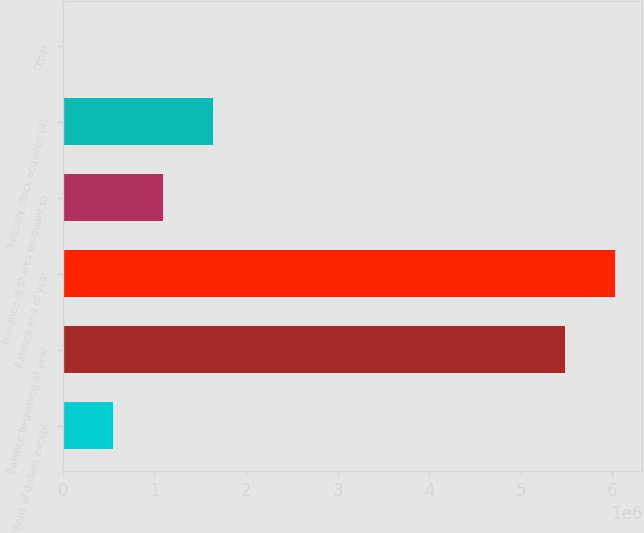Convert chart. <chart><loc_0><loc_0><loc_500><loc_500><bar_chart><fcel>In millions of dollars except<fcel>Balance beginning of year<fcel>Balance end of year<fcel>Issuance of shares pursuant to<fcel>Treasury stock acquired (4)<fcel>Other<nl><fcel>547896<fcel>5.47742e+06<fcel>6.02514e+06<fcel>1.09562e+06<fcel>1.64335e+06<fcel>172<nl></chart> 